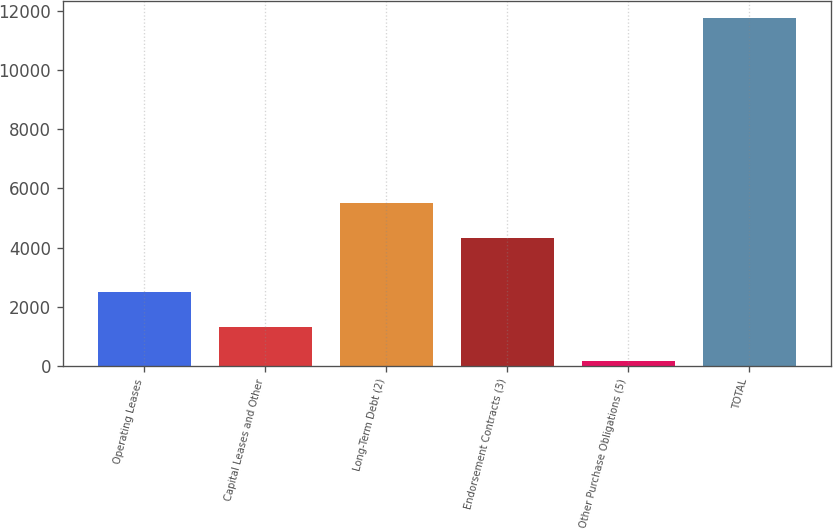Convert chart. <chart><loc_0><loc_0><loc_500><loc_500><bar_chart><fcel>Operating Leases<fcel>Capital Leases and Other<fcel>Long-Term Debt (2)<fcel>Endorsement Contracts (3)<fcel>Other Purchase Obligations (5)<fcel>TOTAL<nl><fcel>2490.4<fcel>1334.7<fcel>5493.7<fcel>4338<fcel>179<fcel>11736<nl></chart> 